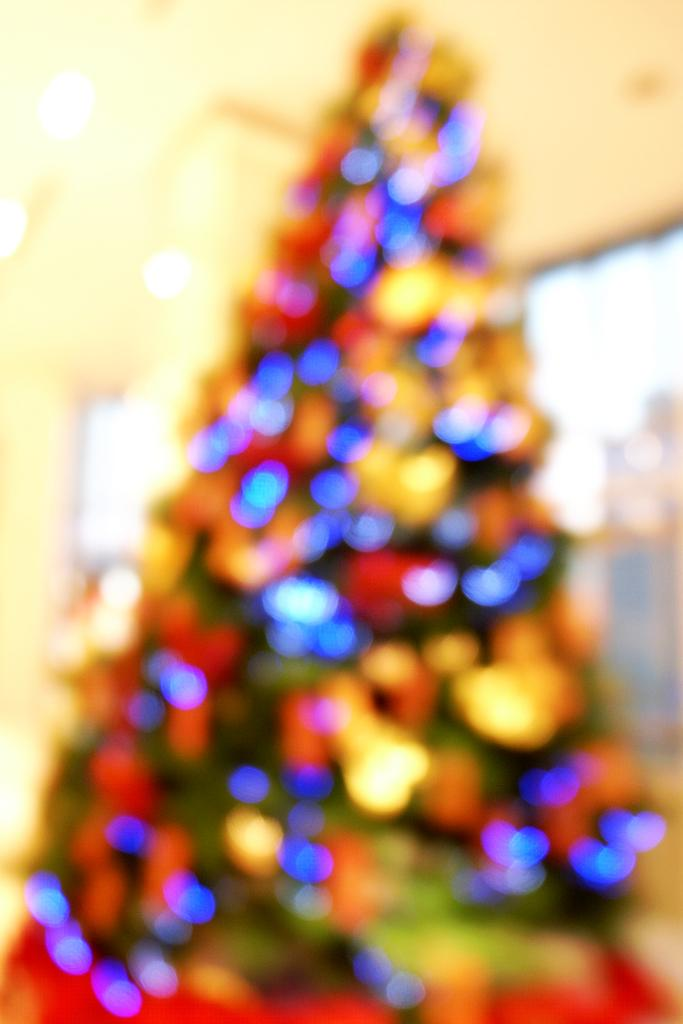What is the quality of the image? The image is a little blurred. Where was the image taken? The image was taken indoors. What is the main subject of the image? There is a Christmas tree in the middle of the image. How is the Christmas tree decorated? The Christmas tree is decorated with lights and decorative items. What type of toy can be seen on the floor in the image? There is no toy or floor visible in the image; it features a blurred indoor scene with a Christmas tree. 